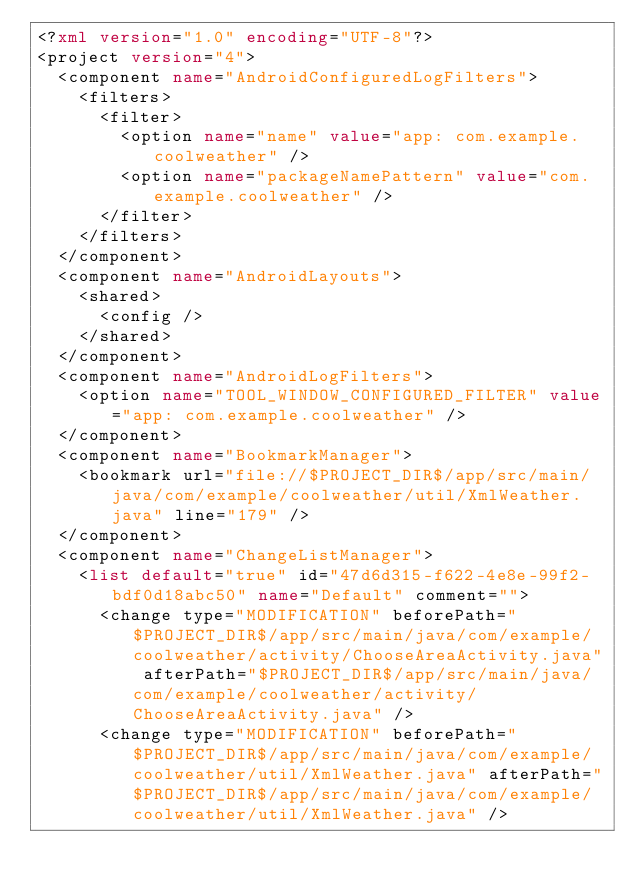Convert code to text. <code><loc_0><loc_0><loc_500><loc_500><_XML_><?xml version="1.0" encoding="UTF-8"?>
<project version="4">
  <component name="AndroidConfiguredLogFilters">
    <filters>
      <filter>
        <option name="name" value="app: com.example.coolweather" />
        <option name="packageNamePattern" value="com.example.coolweather" />
      </filter>
    </filters>
  </component>
  <component name="AndroidLayouts">
    <shared>
      <config />
    </shared>
  </component>
  <component name="AndroidLogFilters">
    <option name="TOOL_WINDOW_CONFIGURED_FILTER" value="app: com.example.coolweather" />
  </component>
  <component name="BookmarkManager">
    <bookmark url="file://$PROJECT_DIR$/app/src/main/java/com/example/coolweather/util/XmlWeather.java" line="179" />
  </component>
  <component name="ChangeListManager">
    <list default="true" id="47d6d315-f622-4e8e-99f2-bdf0d18abc50" name="Default" comment="">
      <change type="MODIFICATION" beforePath="$PROJECT_DIR$/app/src/main/java/com/example/coolweather/activity/ChooseAreaActivity.java" afterPath="$PROJECT_DIR$/app/src/main/java/com/example/coolweather/activity/ChooseAreaActivity.java" />
      <change type="MODIFICATION" beforePath="$PROJECT_DIR$/app/src/main/java/com/example/coolweather/util/XmlWeather.java" afterPath="$PROJECT_DIR$/app/src/main/java/com/example/coolweather/util/XmlWeather.java" /></code> 